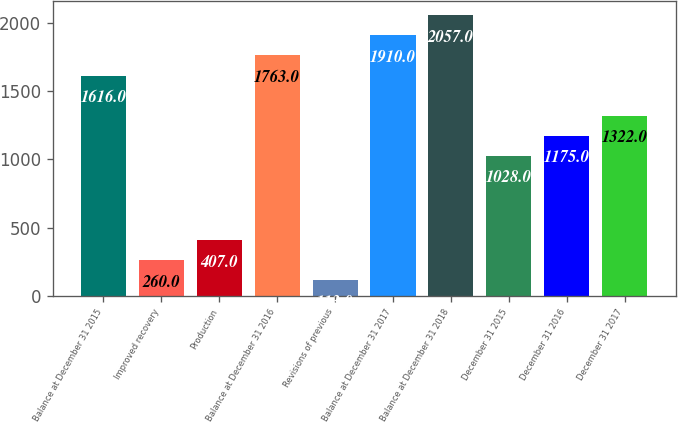Convert chart. <chart><loc_0><loc_0><loc_500><loc_500><bar_chart><fcel>Balance at December 31 2015<fcel>Improved recovery<fcel>Production<fcel>Balance at December 31 2016<fcel>Revisions of previous<fcel>Balance at December 31 2017<fcel>Balance at December 31 2018<fcel>December 31 2015<fcel>December 31 2016<fcel>December 31 2017<nl><fcel>1616<fcel>260<fcel>407<fcel>1763<fcel>113<fcel>1910<fcel>2057<fcel>1028<fcel>1175<fcel>1322<nl></chart> 